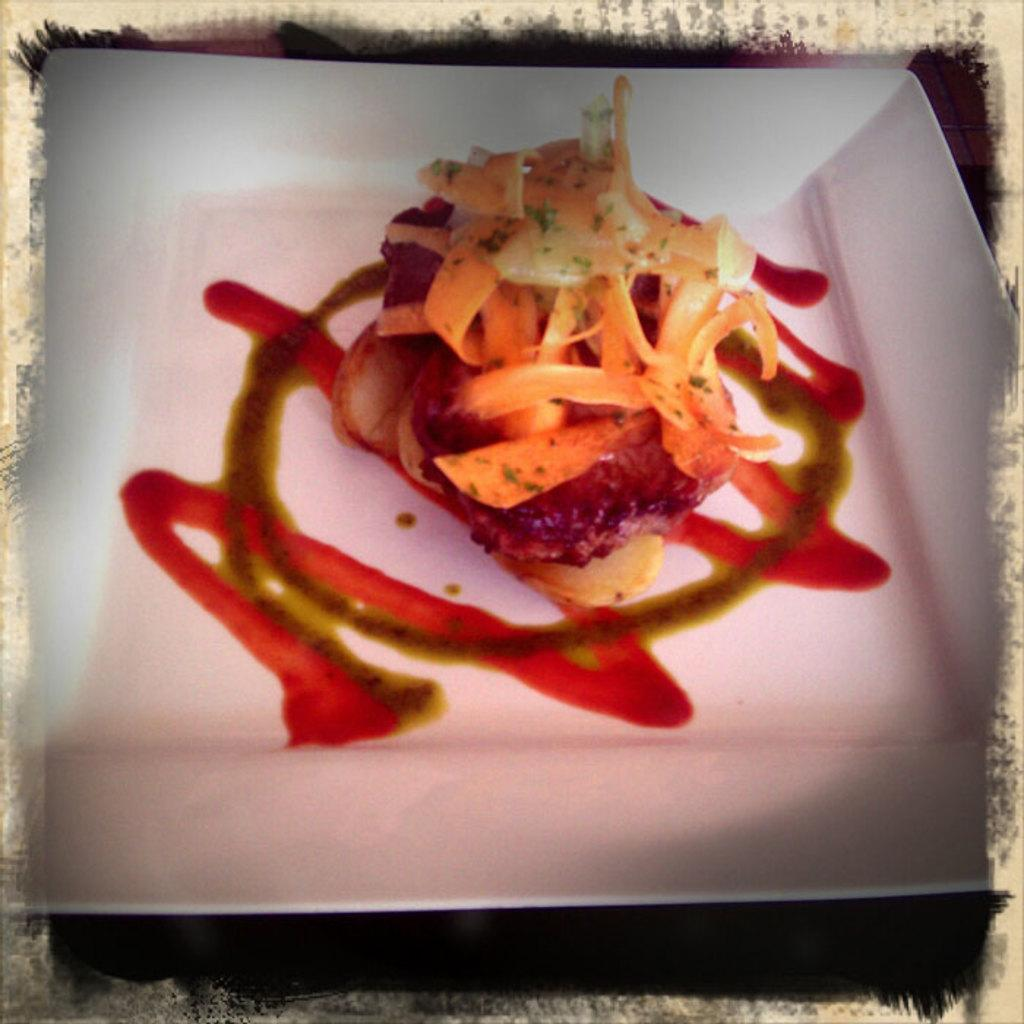What is the main subject of the image? There is a food item in the image. How is the food item arranged or presented in the image? The food item is kept in a plate. What type of light source is used to illuminate the food item in the image? There is no specific information about the light source in the image, as the focus is on the food item and the plate. 